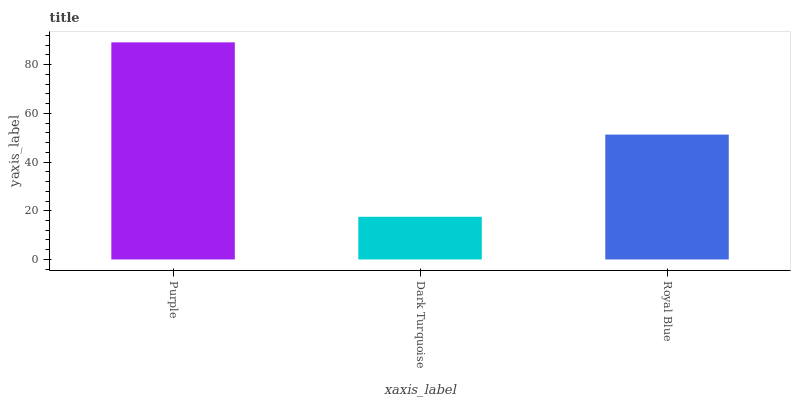Is Dark Turquoise the minimum?
Answer yes or no. Yes. Is Purple the maximum?
Answer yes or no. Yes. Is Royal Blue the minimum?
Answer yes or no. No. Is Royal Blue the maximum?
Answer yes or no. No. Is Royal Blue greater than Dark Turquoise?
Answer yes or no. Yes. Is Dark Turquoise less than Royal Blue?
Answer yes or no. Yes. Is Dark Turquoise greater than Royal Blue?
Answer yes or no. No. Is Royal Blue less than Dark Turquoise?
Answer yes or no. No. Is Royal Blue the high median?
Answer yes or no. Yes. Is Royal Blue the low median?
Answer yes or no. Yes. Is Dark Turquoise the high median?
Answer yes or no. No. Is Purple the low median?
Answer yes or no. No. 